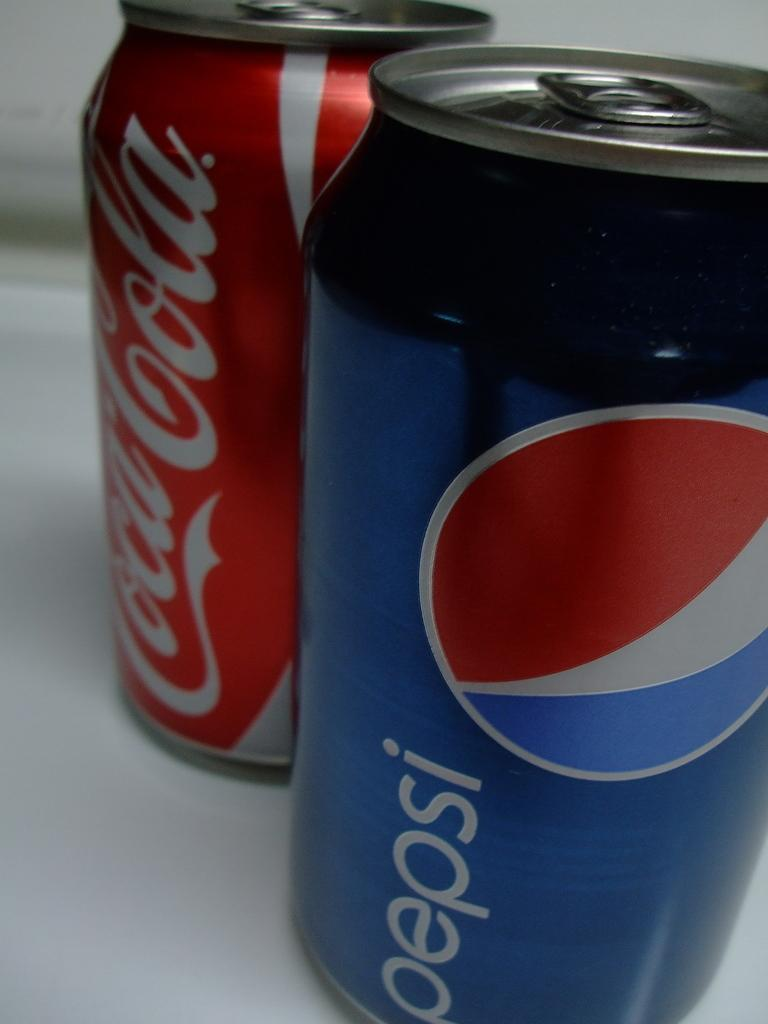<image>
Share a concise interpretation of the image provided. pepsi and coke cans are sitting side by side 